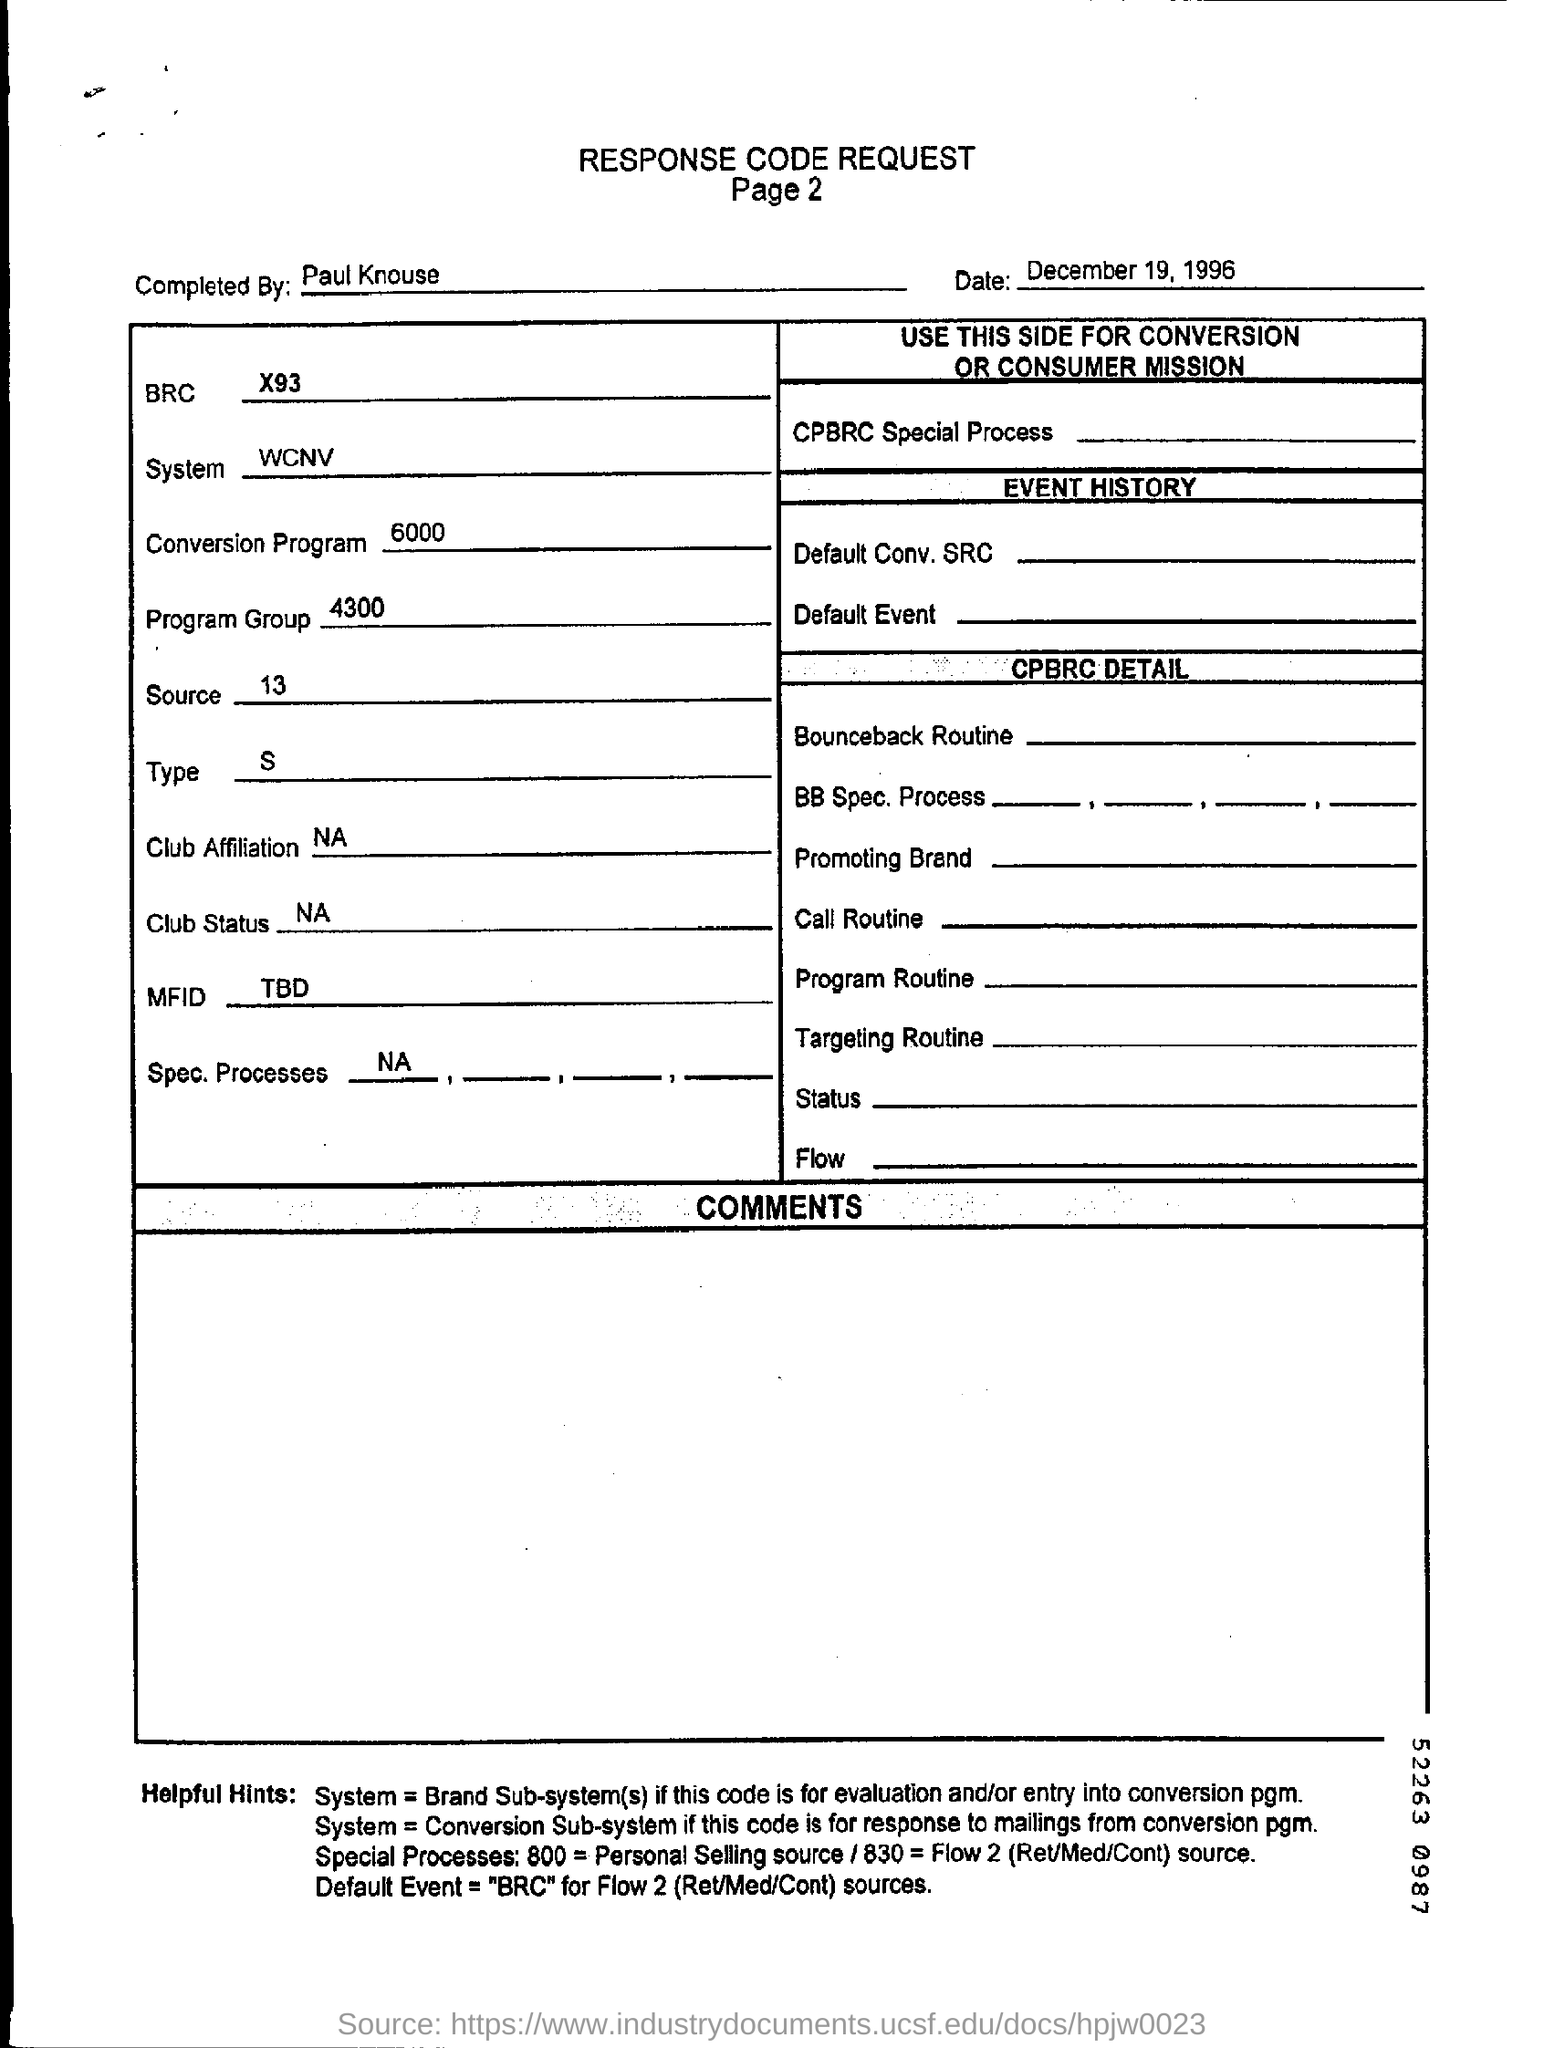Indicate a few pertinent items in this graphic. The document mentions a date of December 19, 1996. The completion of the Response Code Request was done by Paul Knouse. The system that is utilized as per the document is WCNV... The Conversion program value is 6000. Page 2 of this document is mentioned. 